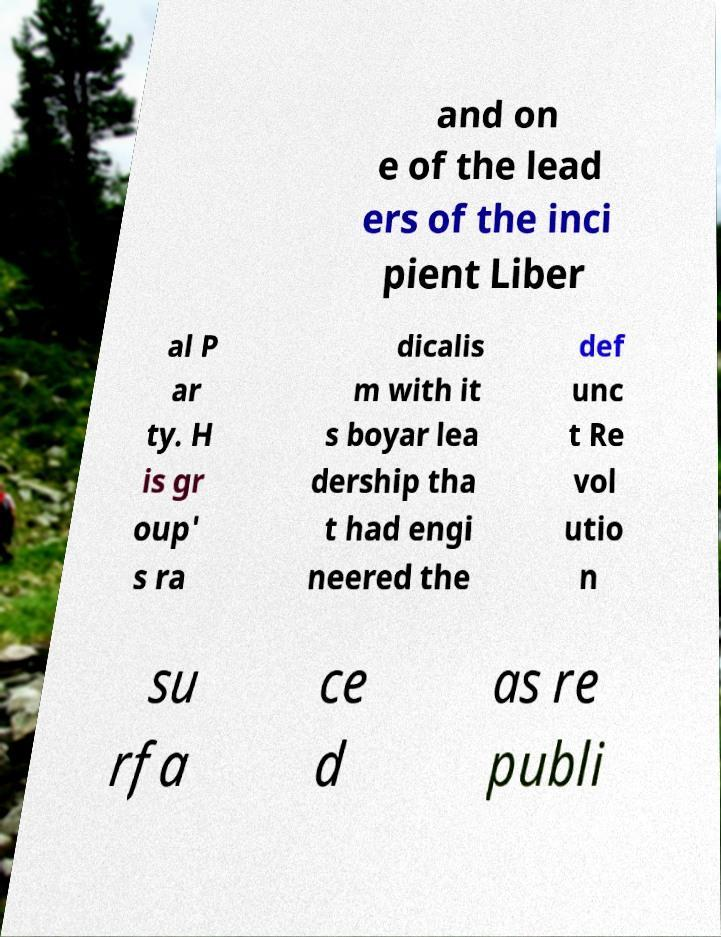Could you extract and type out the text from this image? and on e of the lead ers of the inci pient Liber al P ar ty. H is gr oup' s ra dicalis m with it s boyar lea dership tha t had engi neered the def unc t Re vol utio n su rfa ce d as re publi 